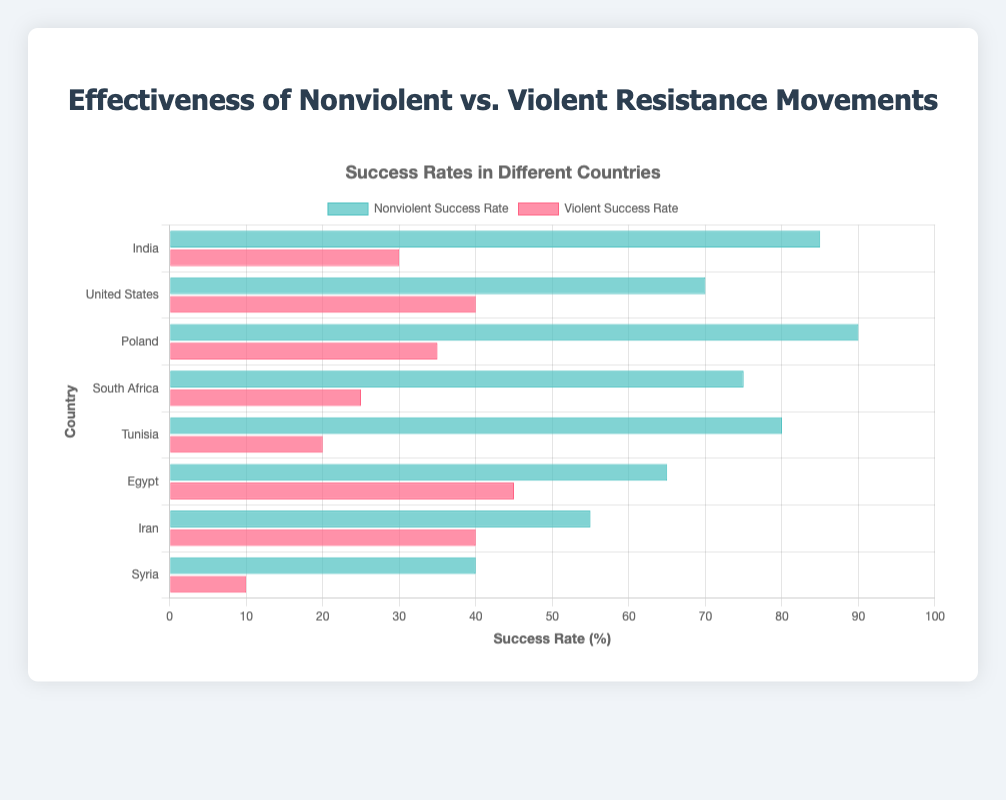Which country has the highest success rate for nonviolent resistance movements? By looking at the horizontal grouped bar chart, we identify the longest blue bars representing nonviolent success rates, and the longest bar is for Poland with a nonviolent success rate of 90%.
Answer: Poland Which country has the lowest success rate for violent resistance movements? By examining the lengths of the red bars representing violent success rates, we see that the shortest bar is for Syria, indicating a violent success rate of 10%.
Answer: Syria What is the difference in success rates between nonviolent and violent movements in India? The success rate for nonviolent movements in India is 85%, and for violent movements, it is 30%. The difference is calculated as 85% - 30% = 55%.
Answer: 55% What is the average nonviolent success rate across all countries? To find the average, sum up the nonviolent success rates for all countries (85 + 70 + 90 + 75 + 80 + 65 + 55 + 40 = 560) and divide by the number of countries (8). The average is 560 / 8 = 70%.
Answer: 70% How does the success rate of violent movements in the United States compare to the success rate of nonviolent movements in Egypt? The chart shows that the violent success rate in the United States is 40%, and the nonviolent success rate in Egypt is 65%. Comparing the two, 40% is less than 65%.
Answer: less than Which country shows a greater success rate for violent movements compared to its nonviolent movements? By comparing the length of bars within each country, all nonviolent bars exceed their corresponding violent bars. Hence, no country shows a greater success rate for violent movements compared to nonviolent movements.
Answer: none What is the combined success rate for nonviolent movements in Tunisia and South Africa? The success rate for nonviolent movements in Tunisia is 80%, and in South Africa, it is 75%. The combined rate is 80% + 75% = 155%.
Answer: 155% Which visual attribute represents the nonviolent success rates in this chart? The horizontal grouped bar chart uses blue bars to represent the success rates of nonviolent resistance movements.
Answer: blue bars Between Egypt and Iran, which country has a higher success rate for violent resistance movements? The red bar for violent success rates shows that Egypt has 45%, while Iran has 40%, making Egypt’s violent success rate higher.
Answer: Egypt 